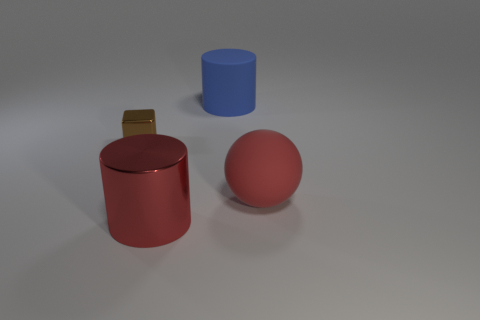What is the material of the cylinder that is the same color as the rubber sphere?
Your answer should be very brief. Metal. What size is the red metallic cylinder?
Offer a terse response. Large. Are there more big blue cylinders behind the red cylinder than large brown matte cubes?
Offer a very short reply. Yes. Are there an equal number of large blue cylinders in front of the blue matte thing and red matte spheres to the left of the small thing?
Ensure brevity in your answer.  Yes. There is a object that is behind the sphere and on the left side of the matte cylinder; what is its color?
Offer a very short reply. Brown. Are there any other things that are the same size as the brown object?
Provide a succinct answer. No. Are there more big cylinders that are right of the tiny brown cube than big red things that are behind the blue object?
Make the answer very short. Yes. There is a cylinder behind the red metal object; does it have the same size as the red metal object?
Keep it short and to the point. Yes. There is a big cylinder behind the big red thing to the right of the large red metal cylinder; how many rubber balls are in front of it?
Offer a very short reply. 1. What is the size of the thing that is both behind the rubber sphere and in front of the big blue matte cylinder?
Your answer should be compact. Small. 